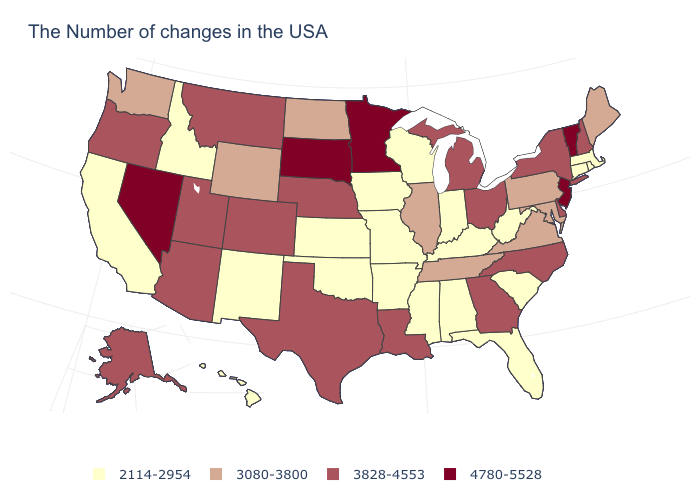What is the value of Ohio?
Concise answer only. 3828-4553. What is the value of Wisconsin?
Be succinct. 2114-2954. Name the states that have a value in the range 3080-3800?
Be succinct. Maine, Maryland, Pennsylvania, Virginia, Tennessee, Illinois, North Dakota, Wyoming, Washington. Among the states that border Oklahoma , does Kansas have the lowest value?
Write a very short answer. Yes. Name the states that have a value in the range 3828-4553?
Concise answer only. New Hampshire, New York, Delaware, North Carolina, Ohio, Georgia, Michigan, Louisiana, Nebraska, Texas, Colorado, Utah, Montana, Arizona, Oregon, Alaska. Does the map have missing data?
Quick response, please. No. Among the states that border New Hampshire , which have the lowest value?
Answer briefly. Massachusetts. What is the lowest value in the West?
Short answer required. 2114-2954. Does Vermont have the highest value in the USA?
Concise answer only. Yes. What is the lowest value in the South?
Write a very short answer. 2114-2954. What is the highest value in states that border Missouri?
Give a very brief answer. 3828-4553. Name the states that have a value in the range 2114-2954?
Give a very brief answer. Massachusetts, Rhode Island, Connecticut, South Carolina, West Virginia, Florida, Kentucky, Indiana, Alabama, Wisconsin, Mississippi, Missouri, Arkansas, Iowa, Kansas, Oklahoma, New Mexico, Idaho, California, Hawaii. What is the highest value in states that border Maryland?
Be succinct. 3828-4553. Name the states that have a value in the range 3080-3800?
Keep it brief. Maine, Maryland, Pennsylvania, Virginia, Tennessee, Illinois, North Dakota, Wyoming, Washington. Which states hav the highest value in the West?
Short answer required. Nevada. 